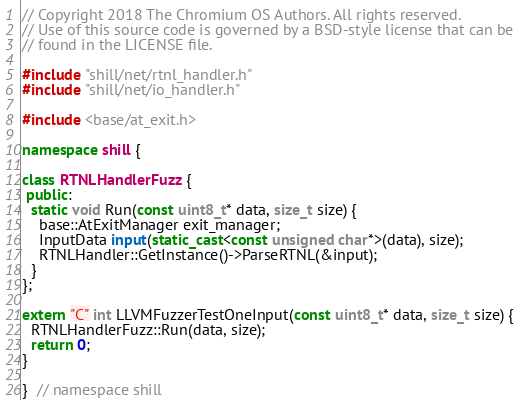Convert code to text. <code><loc_0><loc_0><loc_500><loc_500><_C++_>// Copyright 2018 The Chromium OS Authors. All rights reserved.
// Use of this source code is governed by a BSD-style license that can be
// found in the LICENSE file.

#include "shill/net/rtnl_handler.h"
#include "shill/net/io_handler.h"

#include <base/at_exit.h>

namespace shill {

class RTNLHandlerFuzz {
 public:
  static void Run(const uint8_t* data, size_t size) {
    base::AtExitManager exit_manager;
    InputData input(static_cast<const unsigned char*>(data), size);
    RTNLHandler::GetInstance()->ParseRTNL(&input);
  }
};

extern "C" int LLVMFuzzerTestOneInput(const uint8_t* data, size_t size) {
  RTNLHandlerFuzz::Run(data, size);
  return 0;
}

}  // namespace shill
</code> 